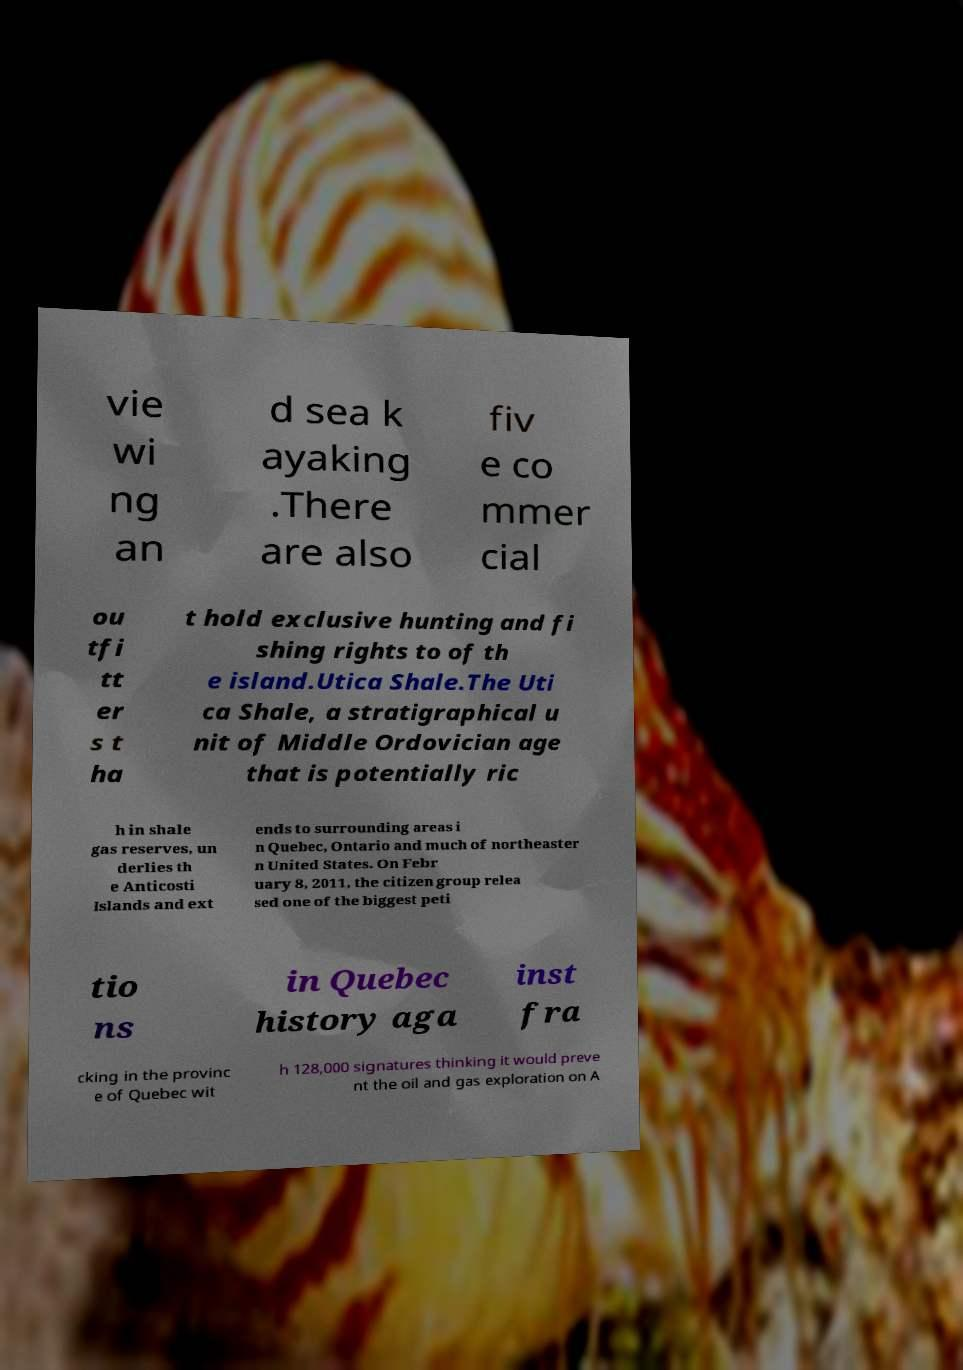Please identify and transcribe the text found in this image. vie wi ng an d sea k ayaking .There are also fiv e co mmer cial ou tfi tt er s t ha t hold exclusive hunting and fi shing rights to of th e island.Utica Shale.The Uti ca Shale, a stratigraphical u nit of Middle Ordovician age that is potentially ric h in shale gas reserves, un derlies th e Anticosti Islands and ext ends to surrounding areas i n Quebec, Ontario and much of northeaster n United States. On Febr uary 8, 2011, the citizen group relea sed one of the biggest peti tio ns in Quebec history aga inst fra cking in the provinc e of Quebec wit h 128,000 signatures thinking it would preve nt the oil and gas exploration on A 